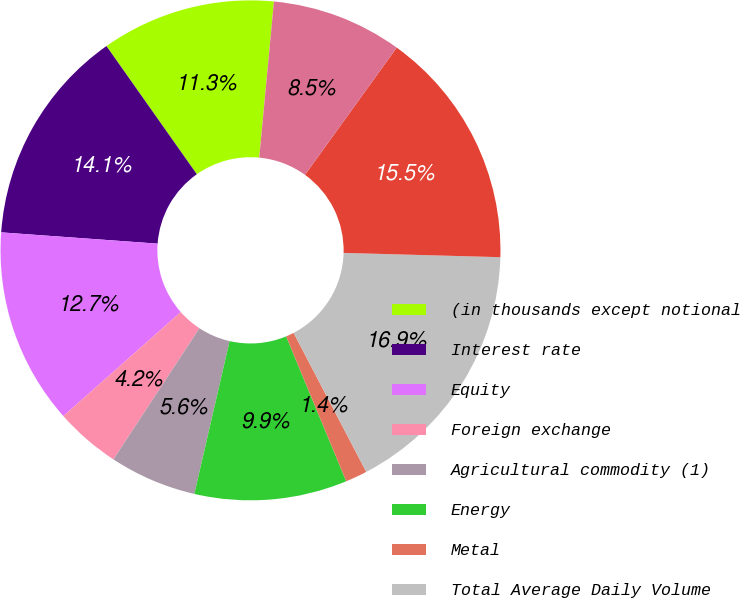Convert chart to OTSL. <chart><loc_0><loc_0><loc_500><loc_500><pie_chart><fcel>(in thousands except notional<fcel>Interest rate<fcel>Equity<fcel>Foreign exchange<fcel>Agricultural commodity (1)<fcel>Energy<fcel>Metal<fcel>Total Average Daily Volume<fcel>Electronic<fcel>Open outcry<nl><fcel>11.27%<fcel>14.08%<fcel>12.68%<fcel>4.23%<fcel>5.63%<fcel>9.86%<fcel>1.41%<fcel>16.9%<fcel>15.49%<fcel>8.45%<nl></chart> 